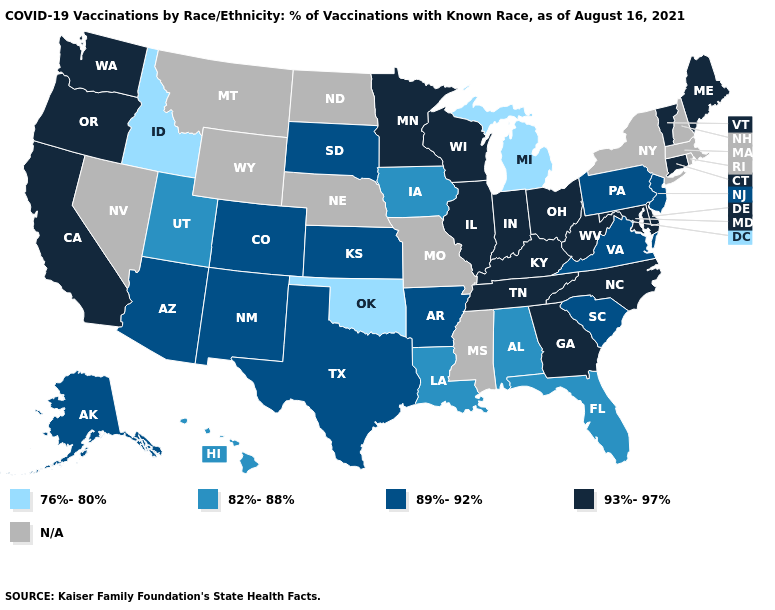Does West Virginia have the lowest value in the USA?
Quick response, please. No. Among the states that border South Dakota , which have the lowest value?
Quick response, please. Iowa. Does West Virginia have the highest value in the USA?
Short answer required. Yes. How many symbols are there in the legend?
Quick response, please. 5. Name the states that have a value in the range 76%-80%?
Short answer required. Idaho, Michigan, Oklahoma. Name the states that have a value in the range 76%-80%?
Concise answer only. Idaho, Michigan, Oklahoma. What is the lowest value in the West?
Be succinct. 76%-80%. Among the states that border Missouri , does Kentucky have the lowest value?
Keep it brief. No. Which states hav the highest value in the MidWest?
Write a very short answer. Illinois, Indiana, Minnesota, Ohio, Wisconsin. What is the highest value in the West ?
Keep it brief. 93%-97%. Does Maine have the highest value in the USA?
Keep it brief. Yes. Name the states that have a value in the range 93%-97%?
Write a very short answer. California, Connecticut, Delaware, Georgia, Illinois, Indiana, Kentucky, Maine, Maryland, Minnesota, North Carolina, Ohio, Oregon, Tennessee, Vermont, Washington, West Virginia, Wisconsin. What is the value of Kentucky?
Short answer required. 93%-97%. What is the value of South Carolina?
Answer briefly. 89%-92%. 